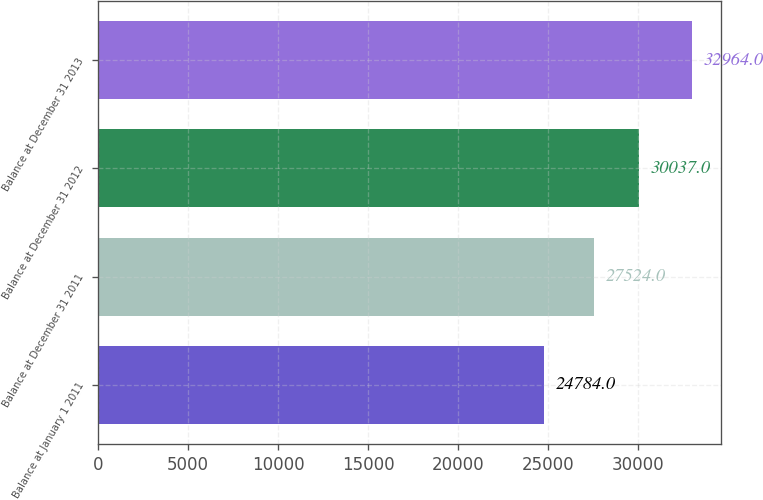<chart> <loc_0><loc_0><loc_500><loc_500><bar_chart><fcel>Balance at January 1 2011<fcel>Balance at December 31 2011<fcel>Balance at December 31 2012<fcel>Balance at December 31 2013<nl><fcel>24784<fcel>27524<fcel>30037<fcel>32964<nl></chart> 